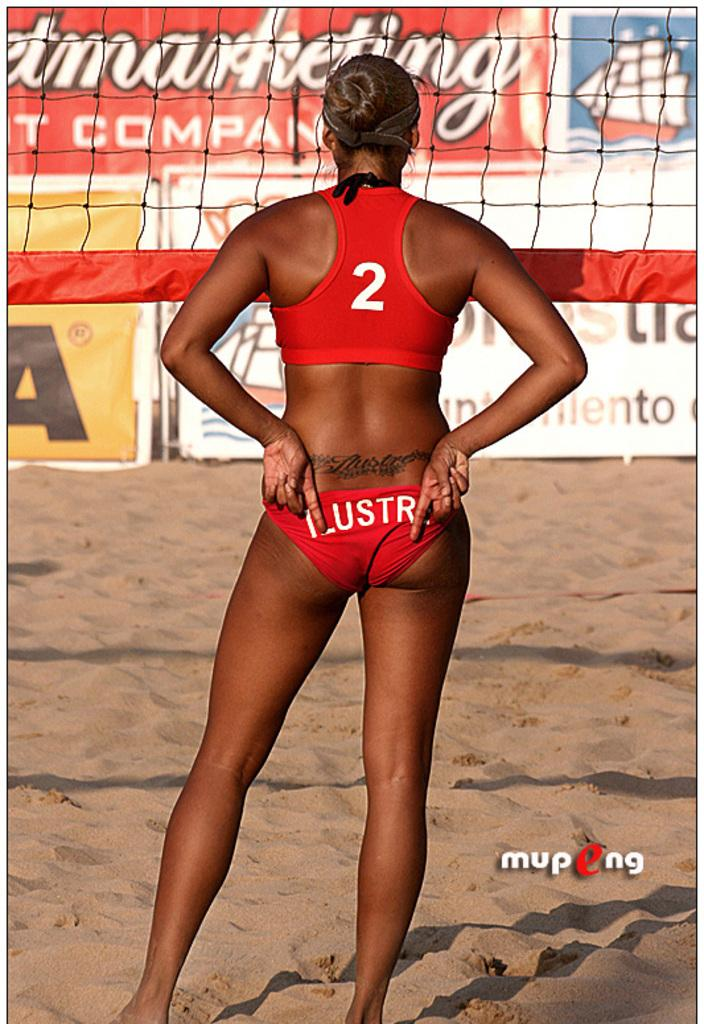Provide a one-sentence caption for the provided image. The beach volleyball player displayed a tramp stamp and the number 2. 